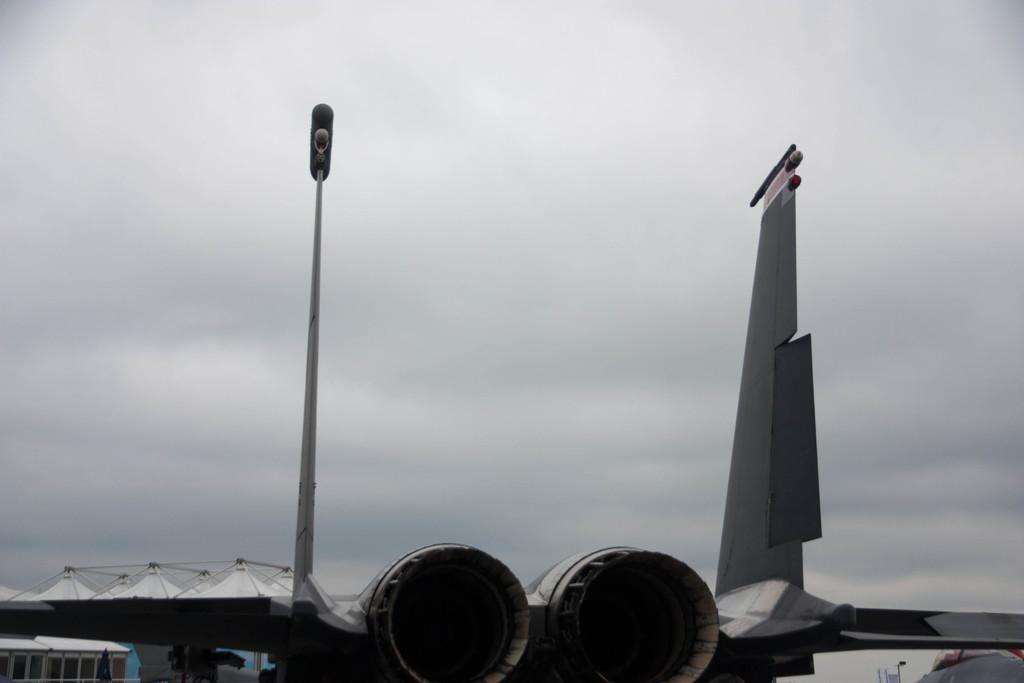Please provide a concise description of this image. In the foreground of the picture we can see an aircraft. On the left there are buildings. At the top it is sky. The sky is cloudy. 